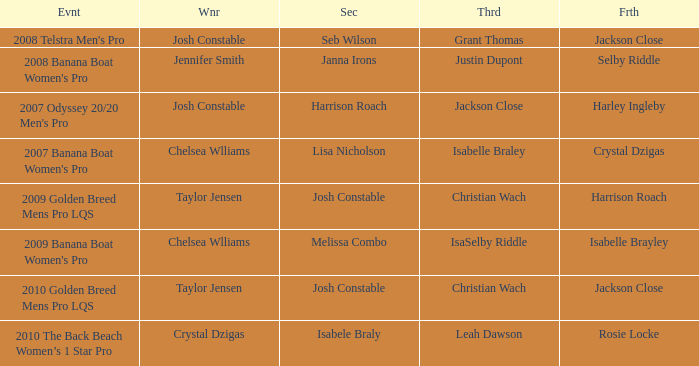Who was Fourth in the 2008 Telstra Men's Pro Event? Jackson Close. 